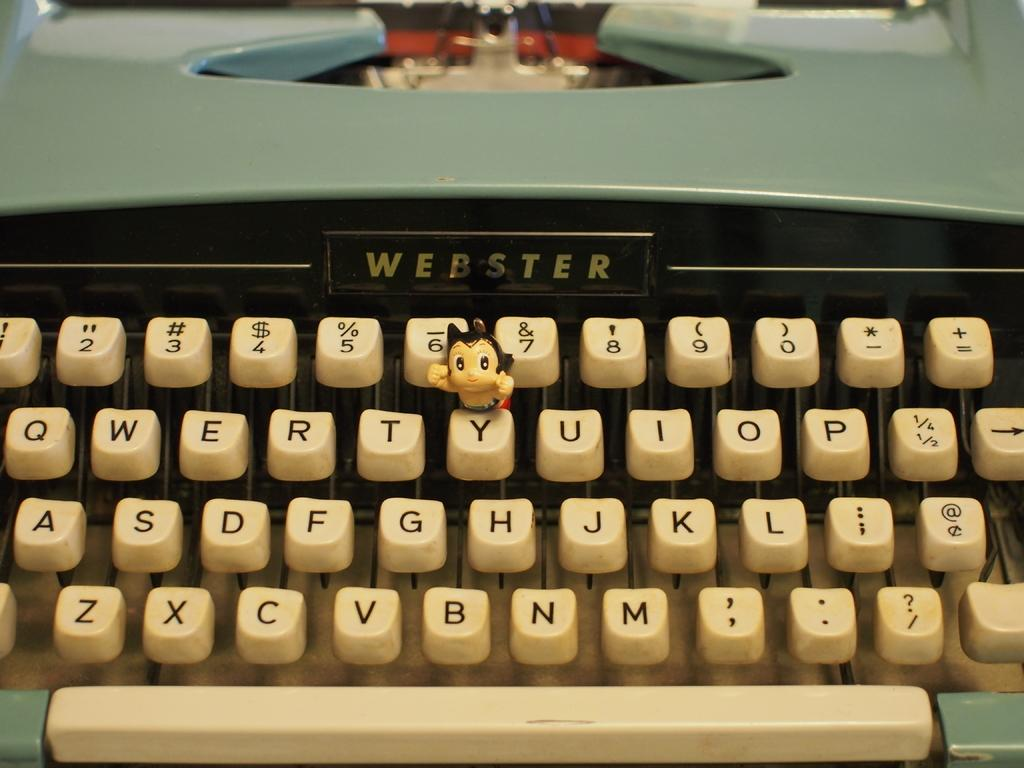<image>
Provide a brief description of the given image. An old Webster typewriter with white keys and a blue cover. 